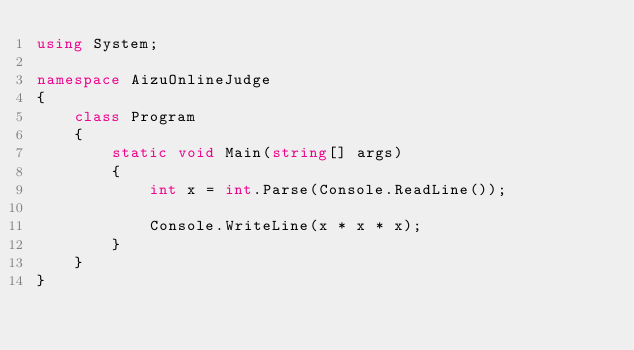<code> <loc_0><loc_0><loc_500><loc_500><_C#_>using System;

namespace AizuOnlineJudge
{
    class Program
    {
        static void Main(string[] args)
        {
            int x = int.Parse(Console.ReadLine());

            Console.WriteLine(x * x * x);
        }
    }
}

</code> 